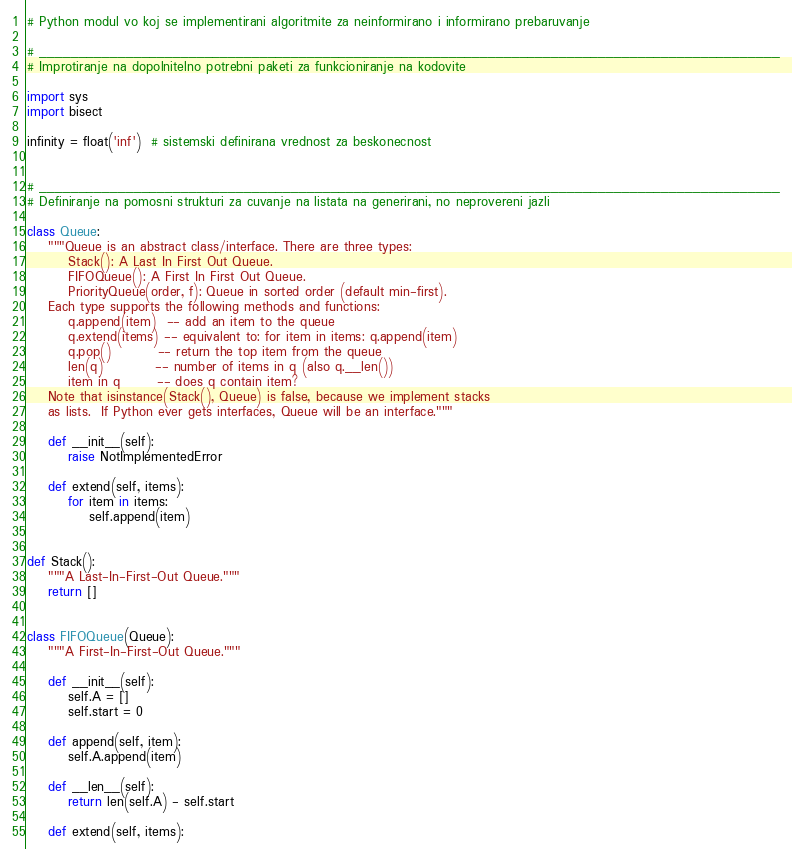<code> <loc_0><loc_0><loc_500><loc_500><_Python_># Python modul vo koj se implementirani algoritmite za neinformirano i informirano prebaruvanje

# ______________________________________________________________________________________________
# Improtiranje na dopolnitelno potrebni paketi za funkcioniranje na kodovite

import sys
import bisect

infinity = float('inf')  # sistemski definirana vrednost za beskonecnost


# ______________________________________________________________________________________________
# Definiranje na pomosni strukturi za cuvanje na listata na generirani, no neprovereni jazli

class Queue:
    """Queue is an abstract class/interface. There are three types:
        Stack(): A Last In First Out Queue.
        FIFOQueue(): A First In First Out Queue.
        PriorityQueue(order, f): Queue in sorted order (default min-first).
    Each type supports the following methods and functions:
        q.append(item)  -- add an item to the queue
        q.extend(items) -- equivalent to: for item in items: q.append(item)
        q.pop()         -- return the top item from the queue
        len(q)          -- number of items in q (also q.__len())
        item in q       -- does q contain item?
    Note that isinstance(Stack(), Queue) is false, because we implement stacks
    as lists.  If Python ever gets interfaces, Queue will be an interface."""

    def __init__(self):
        raise NotImplementedError

    def extend(self, items):
        for item in items:
            self.append(item)


def Stack():
    """A Last-In-First-Out Queue."""
    return []


class FIFOQueue(Queue):
    """A First-In-First-Out Queue."""

    def __init__(self):
        self.A = []
        self.start = 0

    def append(self, item):
        self.A.append(item)

    def __len__(self):
        return len(self.A) - self.start

    def extend(self, items):</code> 